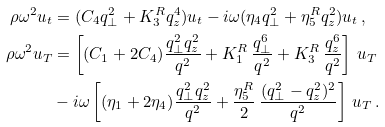<formula> <loc_0><loc_0><loc_500><loc_500>\rho \omega ^ { 2 } u _ { t } & = ( C _ { 4 } q _ { \perp } ^ { 2 } + K _ { 3 } ^ { R } q _ { z } ^ { 4 } ) u _ { t } - i \omega ( \eta _ { 4 } q _ { \perp } ^ { 2 } + \eta _ { 5 } ^ { R } q _ { z } ^ { 2 } ) u _ { t } \, , \\ \rho \omega ^ { 2 } u _ { T } & = \left [ ( C _ { 1 } + 2 C _ { 4 } ) \frac { q _ { \perp } ^ { 2 } q _ { z } ^ { 2 } } { q ^ { 2 } } + K _ { 1 } ^ { R } \, \frac { q _ { \perp } ^ { 6 } } { q ^ { 2 } } + K _ { 3 } ^ { R } \, \frac { q _ { z } ^ { 6 } } { q ^ { 2 } } \right ] \, u _ { T } \\ & - i \omega \left [ ( \eta _ { 1 } + 2 \eta _ { 4 } ) \frac { q _ { \perp } ^ { 2 } q _ { z } ^ { 2 } } { q ^ { 2 } } + \frac { \eta _ { 5 } ^ { R } } { 2 } \, \frac { ( q _ { \perp } ^ { 2 } - q _ { z } ^ { 2 } ) ^ { 2 } } { q ^ { 2 } } \right ] \, u _ { T } \, .</formula> 